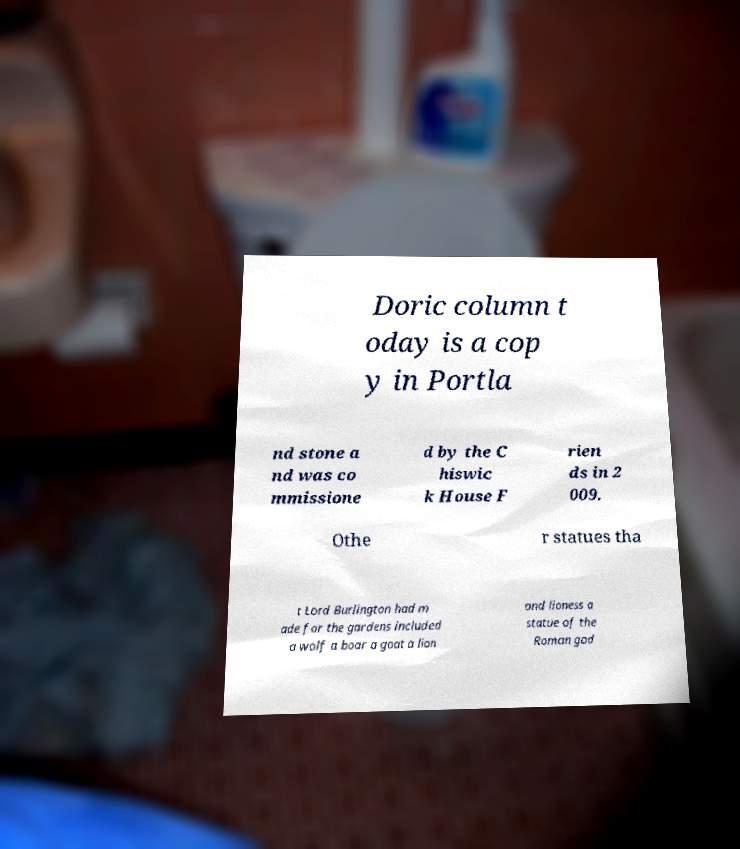What messages or text are displayed in this image? I need them in a readable, typed format. Doric column t oday is a cop y in Portla nd stone a nd was co mmissione d by the C hiswic k House F rien ds in 2 009. Othe r statues tha t Lord Burlington had m ade for the gardens included a wolf a boar a goat a lion and lioness a statue of the Roman god 